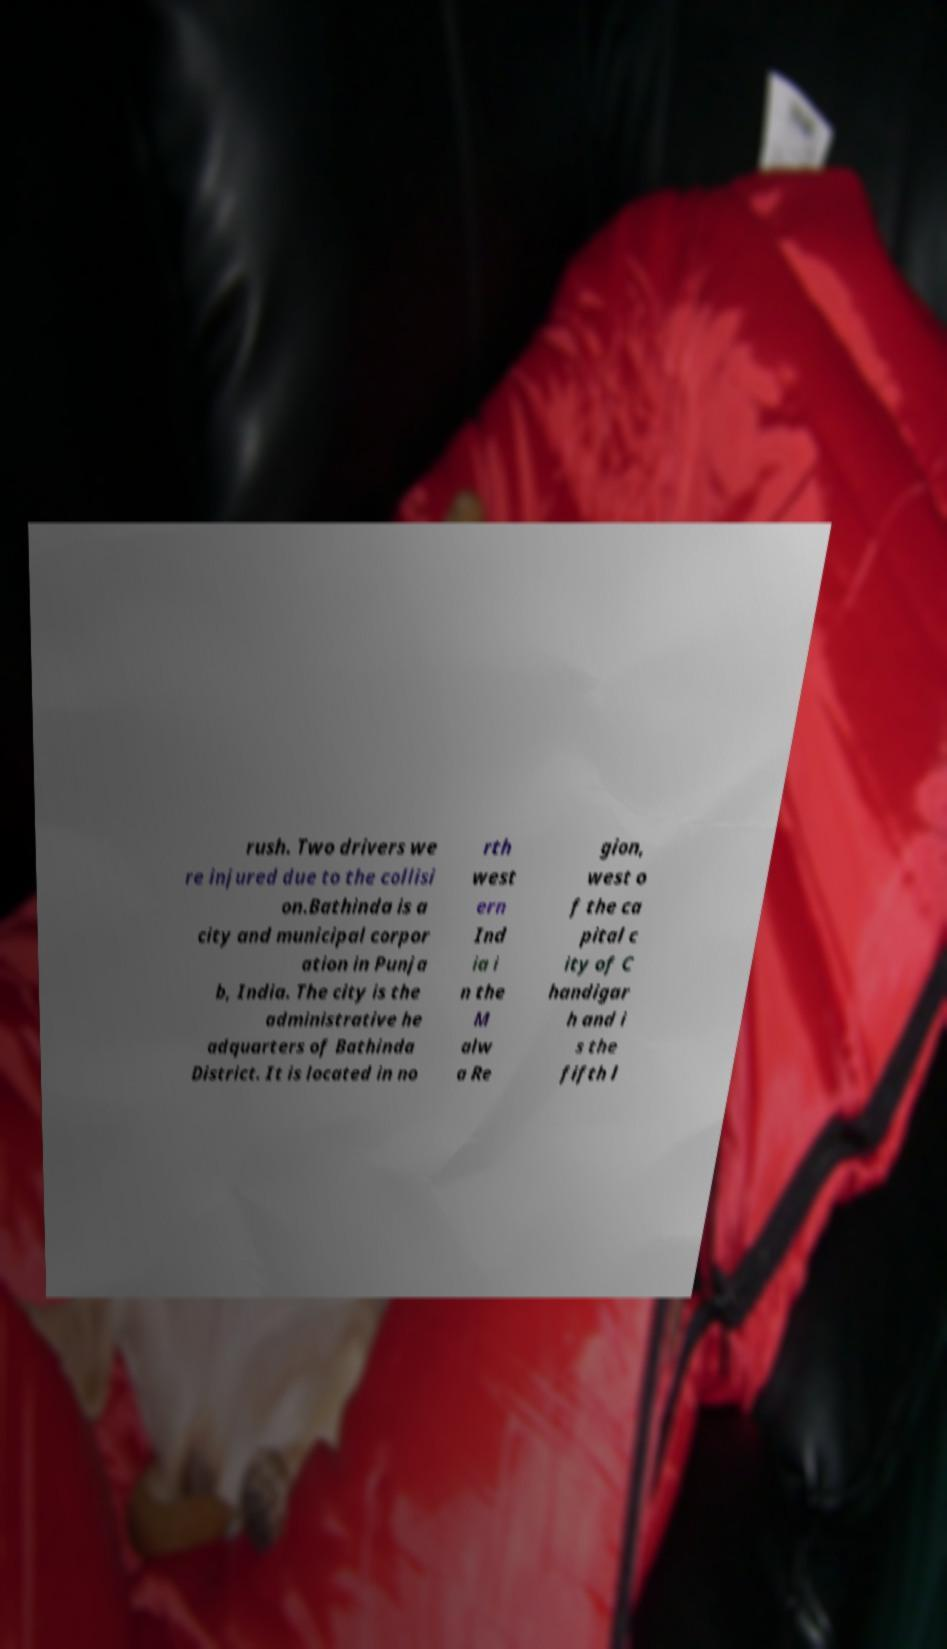Please read and relay the text visible in this image. What does it say? rush. Two drivers we re injured due to the collisi on.Bathinda is a city and municipal corpor ation in Punja b, India. The city is the administrative he adquarters of Bathinda District. It is located in no rth west ern Ind ia i n the M alw a Re gion, west o f the ca pital c ity of C handigar h and i s the fifth l 